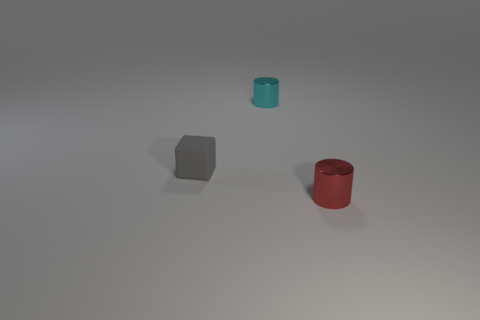Is there a large brown thing of the same shape as the gray object?
Provide a short and direct response. No. What number of rubber things are small cyan things or small gray cubes?
Your response must be concise. 1. The gray object is what shape?
Provide a succinct answer. Cube. How many other small objects have the same material as the small cyan thing?
Provide a succinct answer. 1. The other thing that is the same material as the small red object is what color?
Make the answer very short. Cyan. There is a thing that is in front of the matte cube; is it the same size as the small block?
Ensure brevity in your answer.  Yes. There is another tiny thing that is the same shape as the cyan object; what is its color?
Provide a short and direct response. Red. The tiny object that is on the left side of the metallic thing left of the small thing in front of the gray matte block is what shape?
Ensure brevity in your answer.  Cube. Do the red thing and the gray object have the same shape?
Provide a succinct answer. No. There is a metal object that is to the left of the metallic thing that is in front of the small gray matte block; what shape is it?
Offer a terse response. Cylinder. 